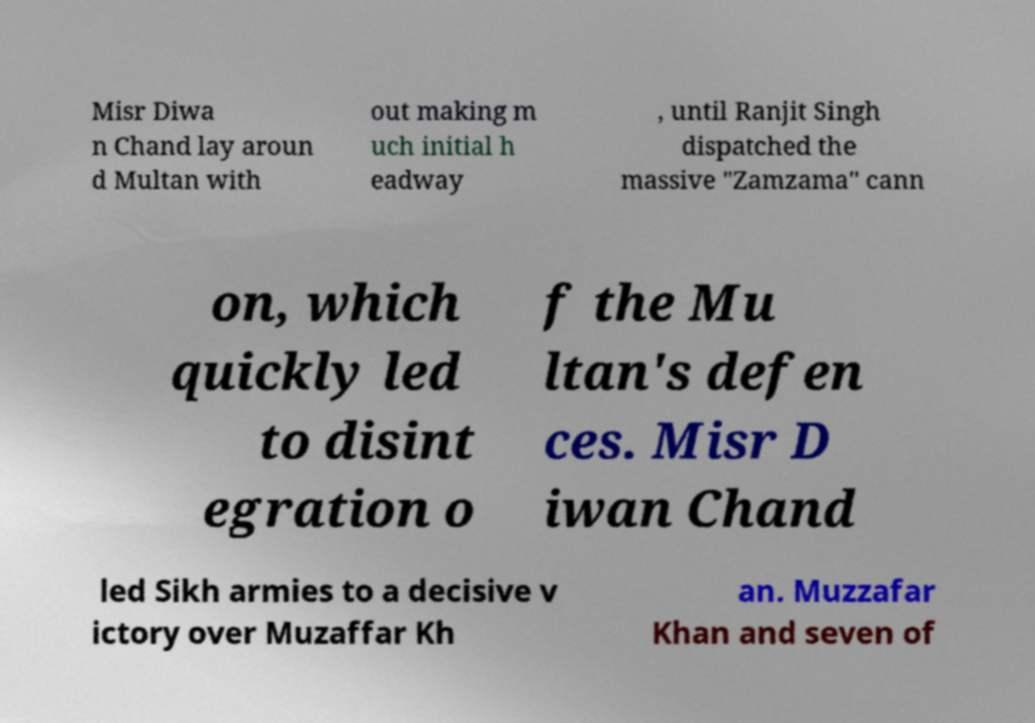Can you accurately transcribe the text from the provided image for me? Misr Diwa n Chand lay aroun d Multan with out making m uch initial h eadway , until Ranjit Singh dispatched the massive "Zamzama" cann on, which quickly led to disint egration o f the Mu ltan's defen ces. Misr D iwan Chand led Sikh armies to a decisive v ictory over Muzaffar Kh an. Muzzafar Khan and seven of 